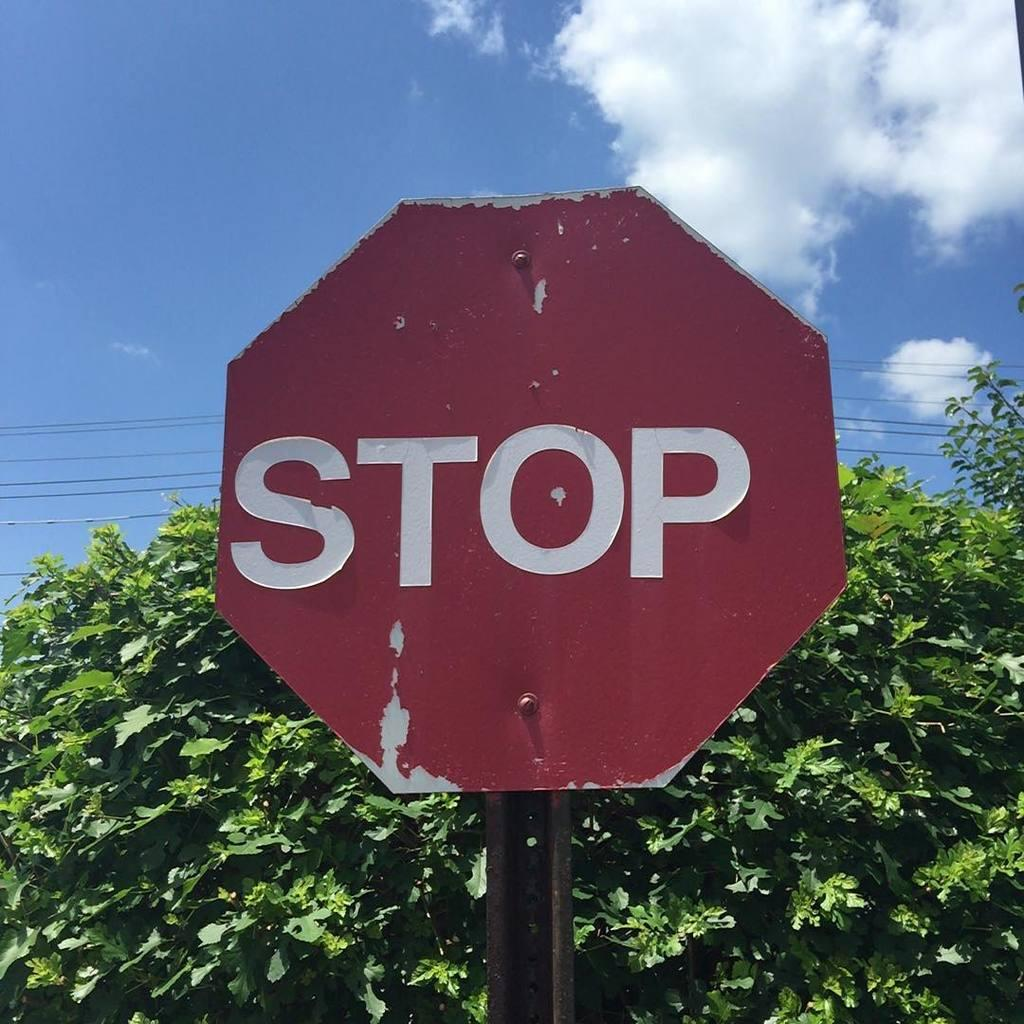<image>
Provide a brief description of the given image. A red sign with STOP in white letters posted in front of a tree. 